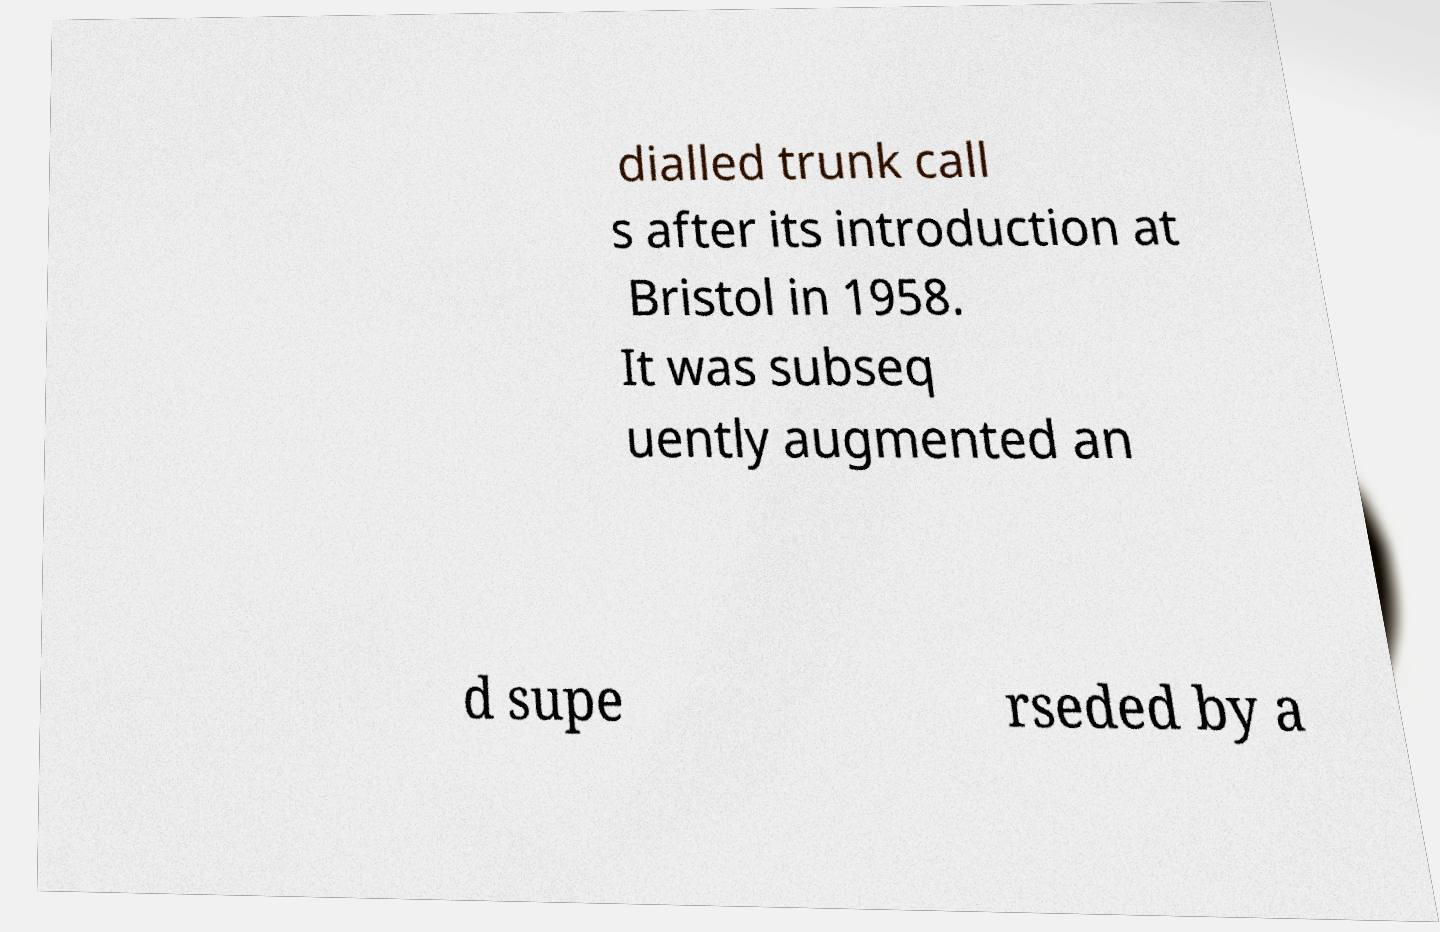I need the written content from this picture converted into text. Can you do that? dialled trunk call s after its introduction at Bristol in 1958. It was subseq uently augmented an d supe rseded by a 